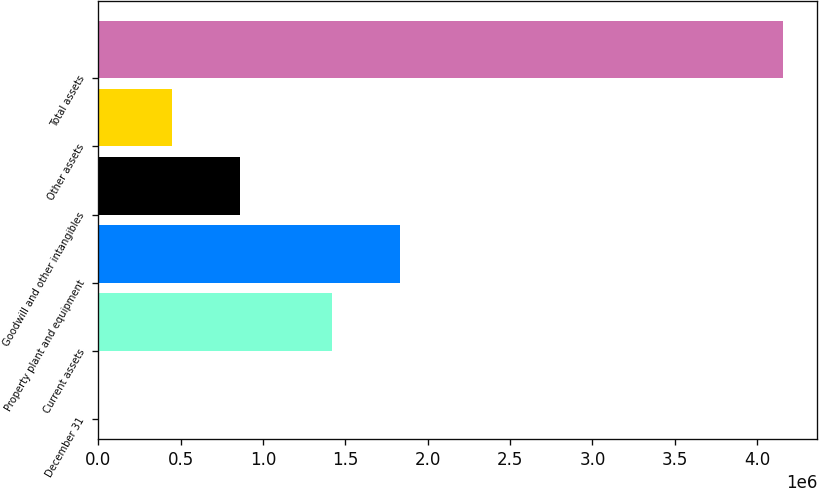Convert chart to OTSL. <chart><loc_0><loc_0><loc_500><loc_500><bar_chart><fcel>December 31<fcel>Current assets<fcel>Property plant and equipment<fcel>Goodwill and other intangibles<fcel>Other assets<fcel>Total assets<nl><fcel>2006<fcel>1.41781e+06<fcel>1.83337e+06<fcel>861740<fcel>446184<fcel>4.15756e+06<nl></chart> 